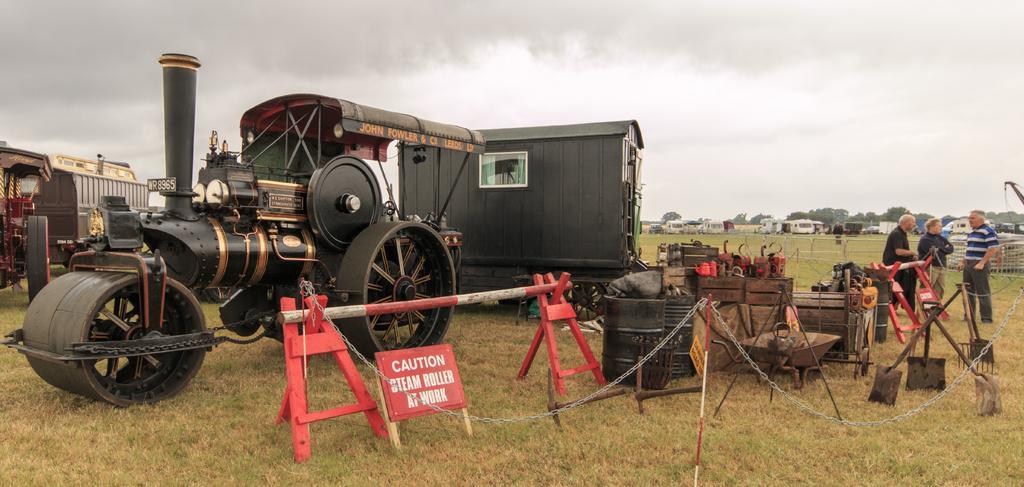How would you summarize this image in a sentence or two? In this image we can see a road roller, vehicle and a carry van, there is caution board, aside to that there are two stands holding a rod, we can see some objects placed on the ground, there are two barrels, and few shovels. there are three persons standing and few vehicles, we can see sky. 